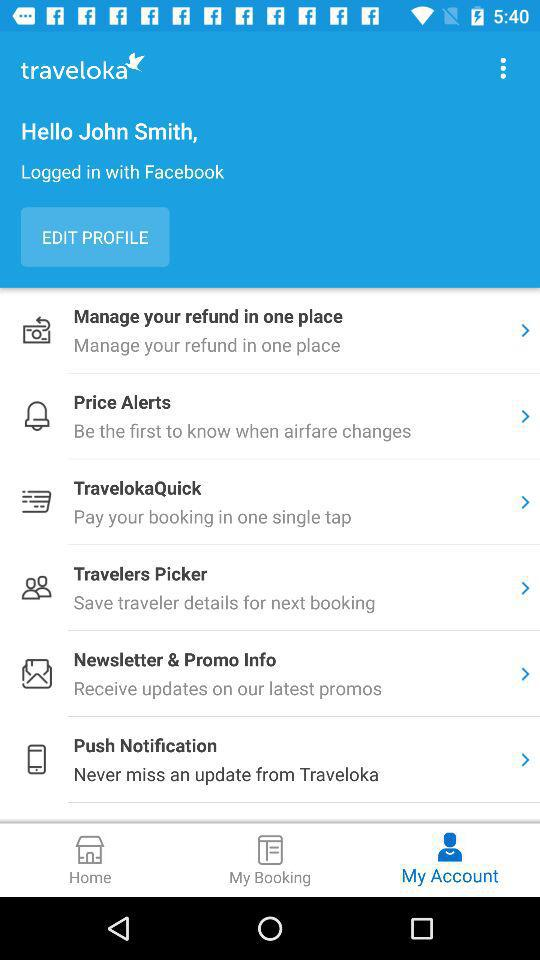What is the application name? The application name is "traveloka". 